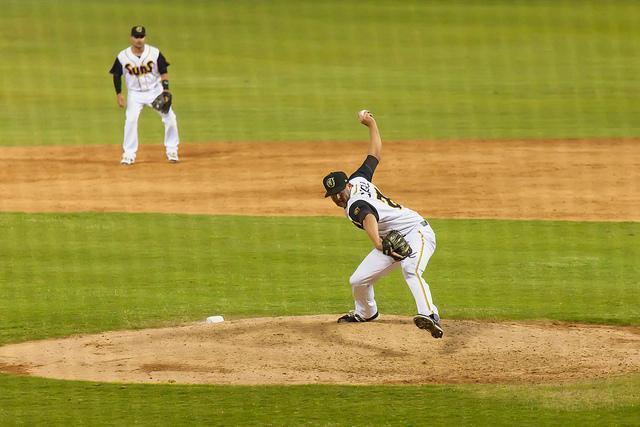How many people are in the picture?
Give a very brief answer. 2. 